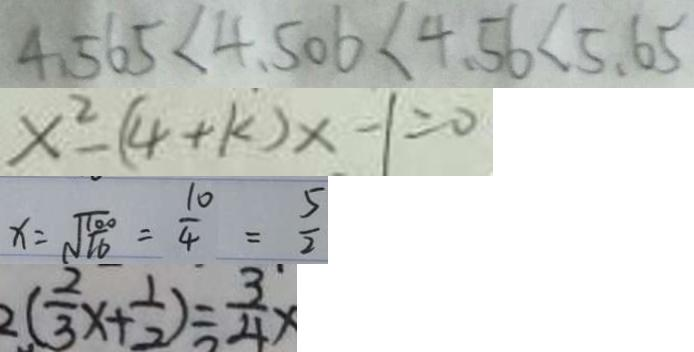Convert formula to latex. <formula><loc_0><loc_0><loc_500><loc_500>4 . 5 6 5 < 4 . 5 0 6 < 4 . 5 6 < 5 . 6 5 
 x ^ { 2 } - ( 4 + k ) x - 1 = 0 
 x = \sqrt { \frac { 1 0 0 } { 1 6 } } = \frac { 1 0 } { 4 } = \frac { 5 } { 2 } 
 2 ( \frac { 2 } { 3 } x + \frac { 1 } { 2 } ) = \frac { 3 } { 4 } x</formula> 